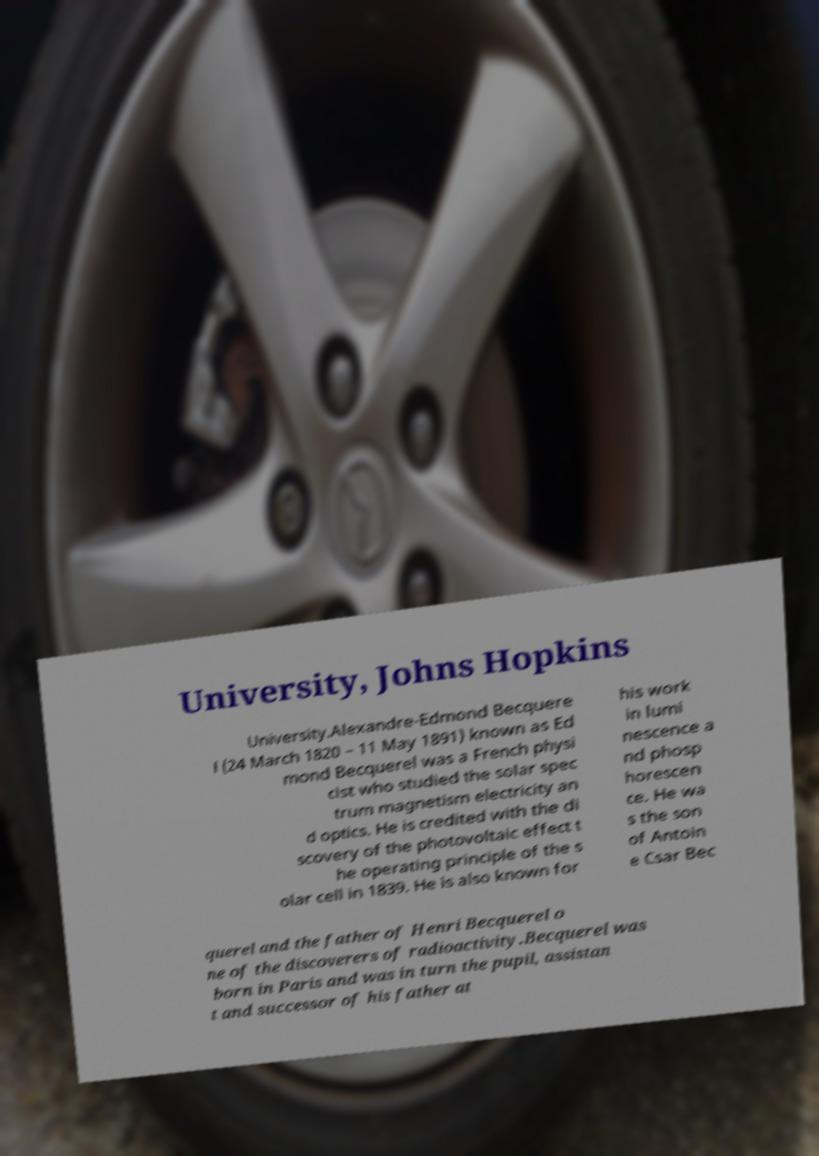I need the written content from this picture converted into text. Can you do that? University, Johns Hopkins University.Alexandre-Edmond Becquere l (24 March 1820 – 11 May 1891) known as Ed mond Becquerel was a French physi cist who studied the solar spec trum magnetism electricity an d optics. He is credited with the di scovery of the photovoltaic effect t he operating principle of the s olar cell in 1839. He is also known for his work in lumi nescence a nd phosp horescen ce. He wa s the son of Antoin e Csar Bec querel and the father of Henri Becquerel o ne of the discoverers of radioactivity.Becquerel was born in Paris and was in turn the pupil, assistan t and successor of his father at 